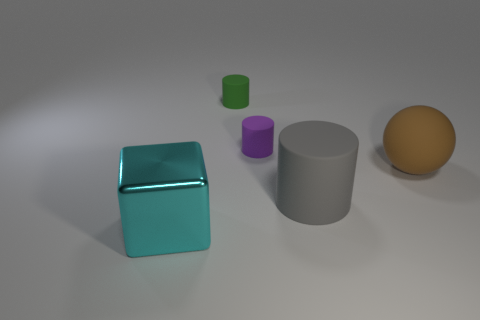What number of green cylinders have the same size as the gray rubber thing?
Your response must be concise. 0. What number of tiny cylinders are there?
Make the answer very short. 2. Do the large gray cylinder and the big thing on the left side of the large cylinder have the same material?
Keep it short and to the point. No. How many green objects are either metallic things or large rubber balls?
Your response must be concise. 0. What is the size of the purple cylinder that is the same material as the large brown ball?
Offer a terse response. Small. How many other big cyan metal things have the same shape as the big metal object?
Offer a very short reply. 0. Is the number of cyan cubes that are right of the brown thing greater than the number of big blocks to the left of the gray matte cylinder?
Your answer should be compact. No. Is the color of the big metal block the same as the small thing behind the small purple matte object?
Offer a terse response. No. What is the material of the cyan object that is the same size as the brown sphere?
Give a very brief answer. Metal. What number of objects are blocks or matte objects on the right side of the purple thing?
Keep it short and to the point. 3. 